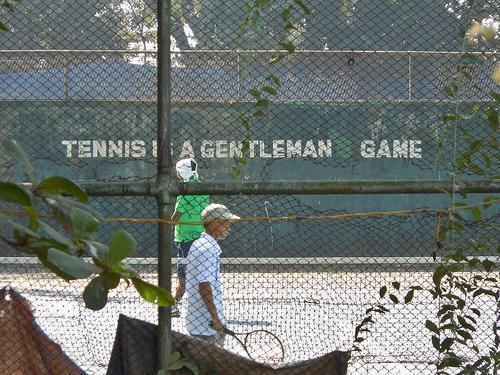How many people are on the court?
Give a very brief answer. 2. How many full words are on the wall to the left of the verticle fence post?
Give a very brief answer. 1. 